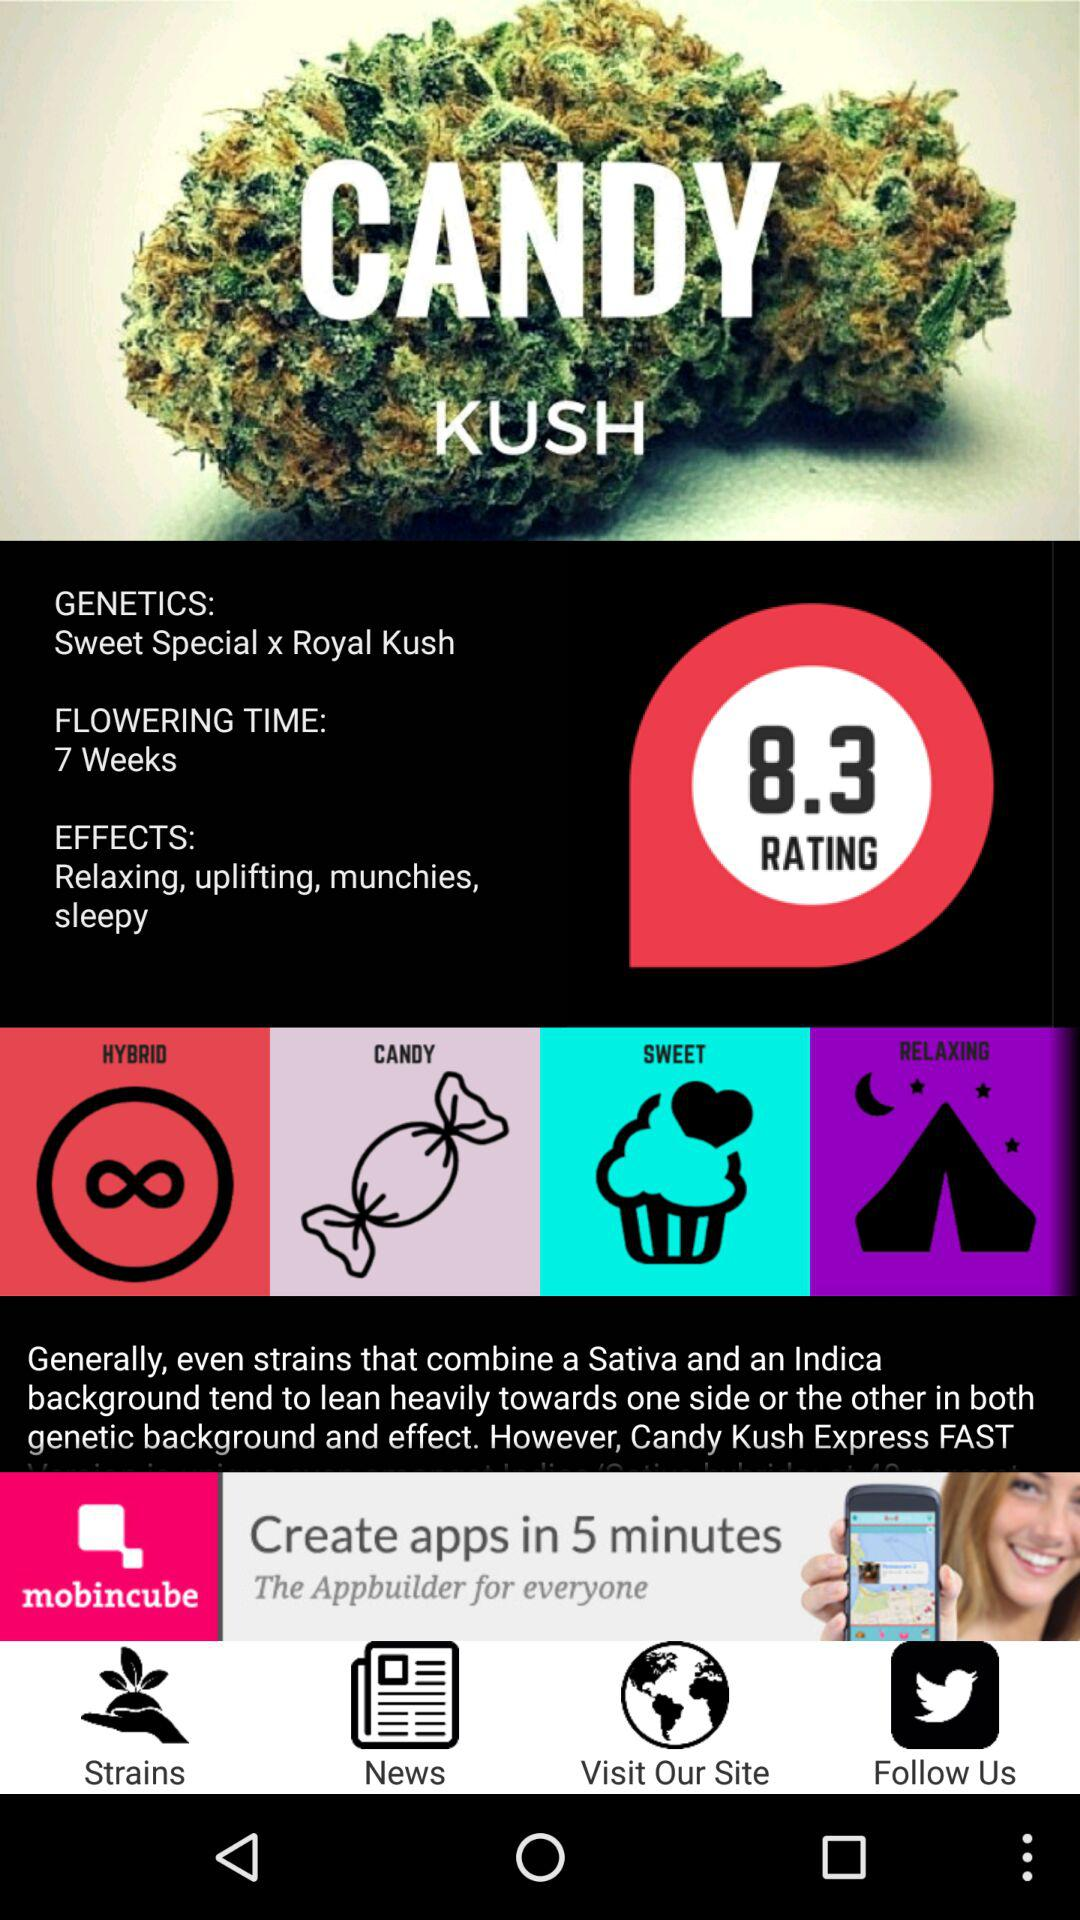What are the effects of "CANDY KUSH" intake? The effects of "CANDY KUSH" intake are "Relaxing", "uplifting", "munchies" and "sleepy". 